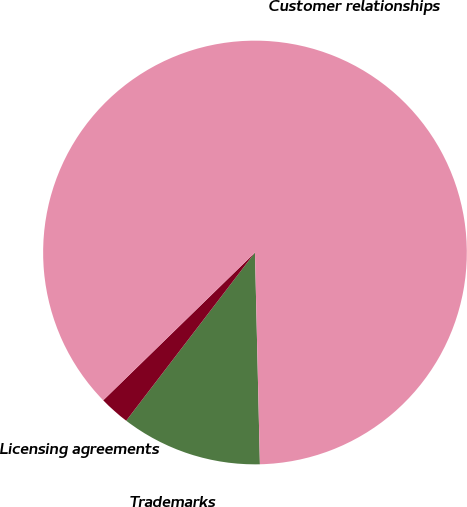Convert chart to OTSL. <chart><loc_0><loc_0><loc_500><loc_500><pie_chart><fcel>Trademarks<fcel>Licensing agreements<fcel>Customer relationships<nl><fcel>10.77%<fcel>2.31%<fcel>86.92%<nl></chart> 